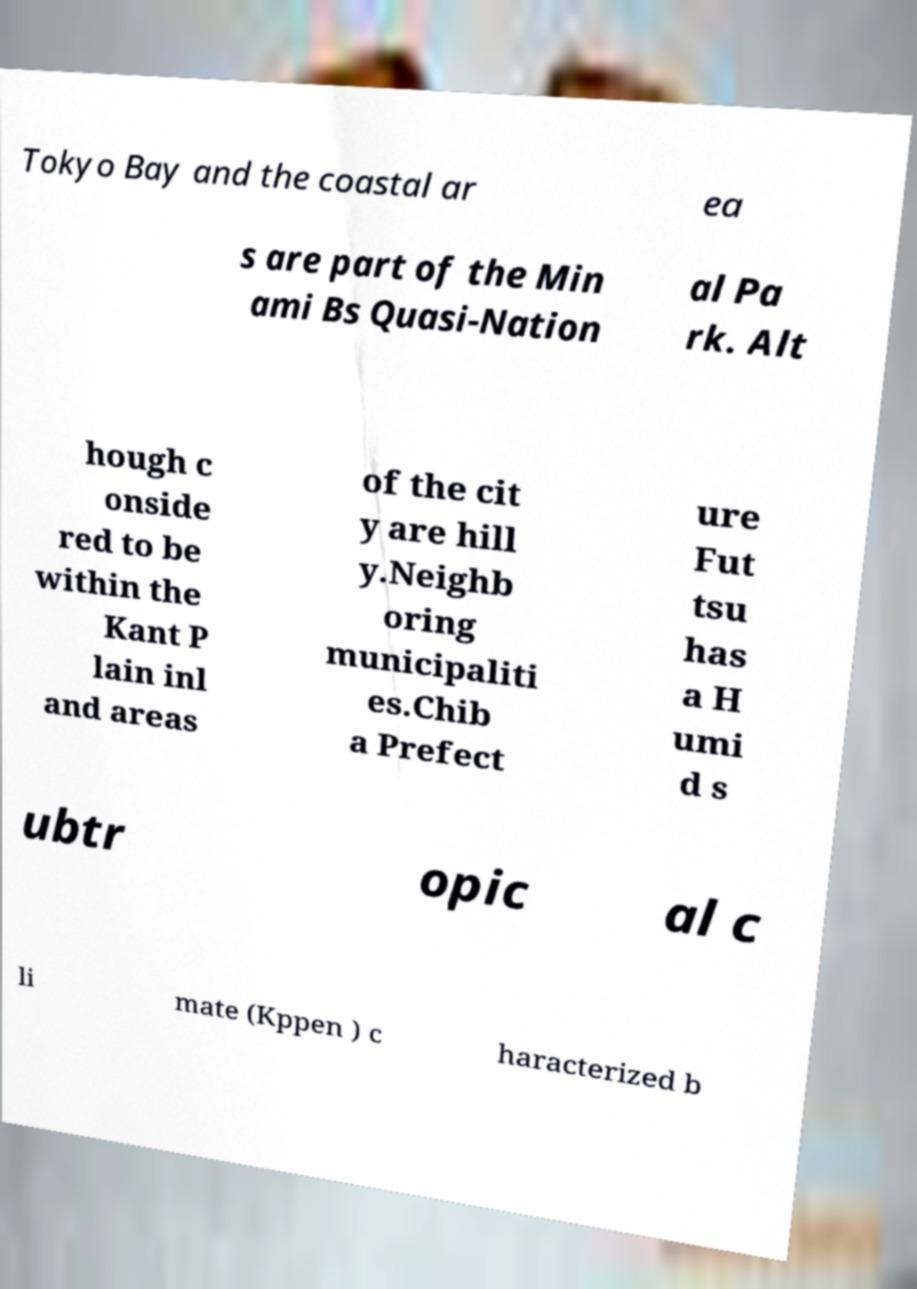Can you read and provide the text displayed in the image?This photo seems to have some interesting text. Can you extract and type it out for me? Tokyo Bay and the coastal ar ea s are part of the Min ami Bs Quasi-Nation al Pa rk. Alt hough c onside red to be within the Kant P lain inl and areas of the cit y are hill y.Neighb oring municipaliti es.Chib a Prefect ure Fut tsu has a H umi d s ubtr opic al c li mate (Kppen ) c haracterized b 